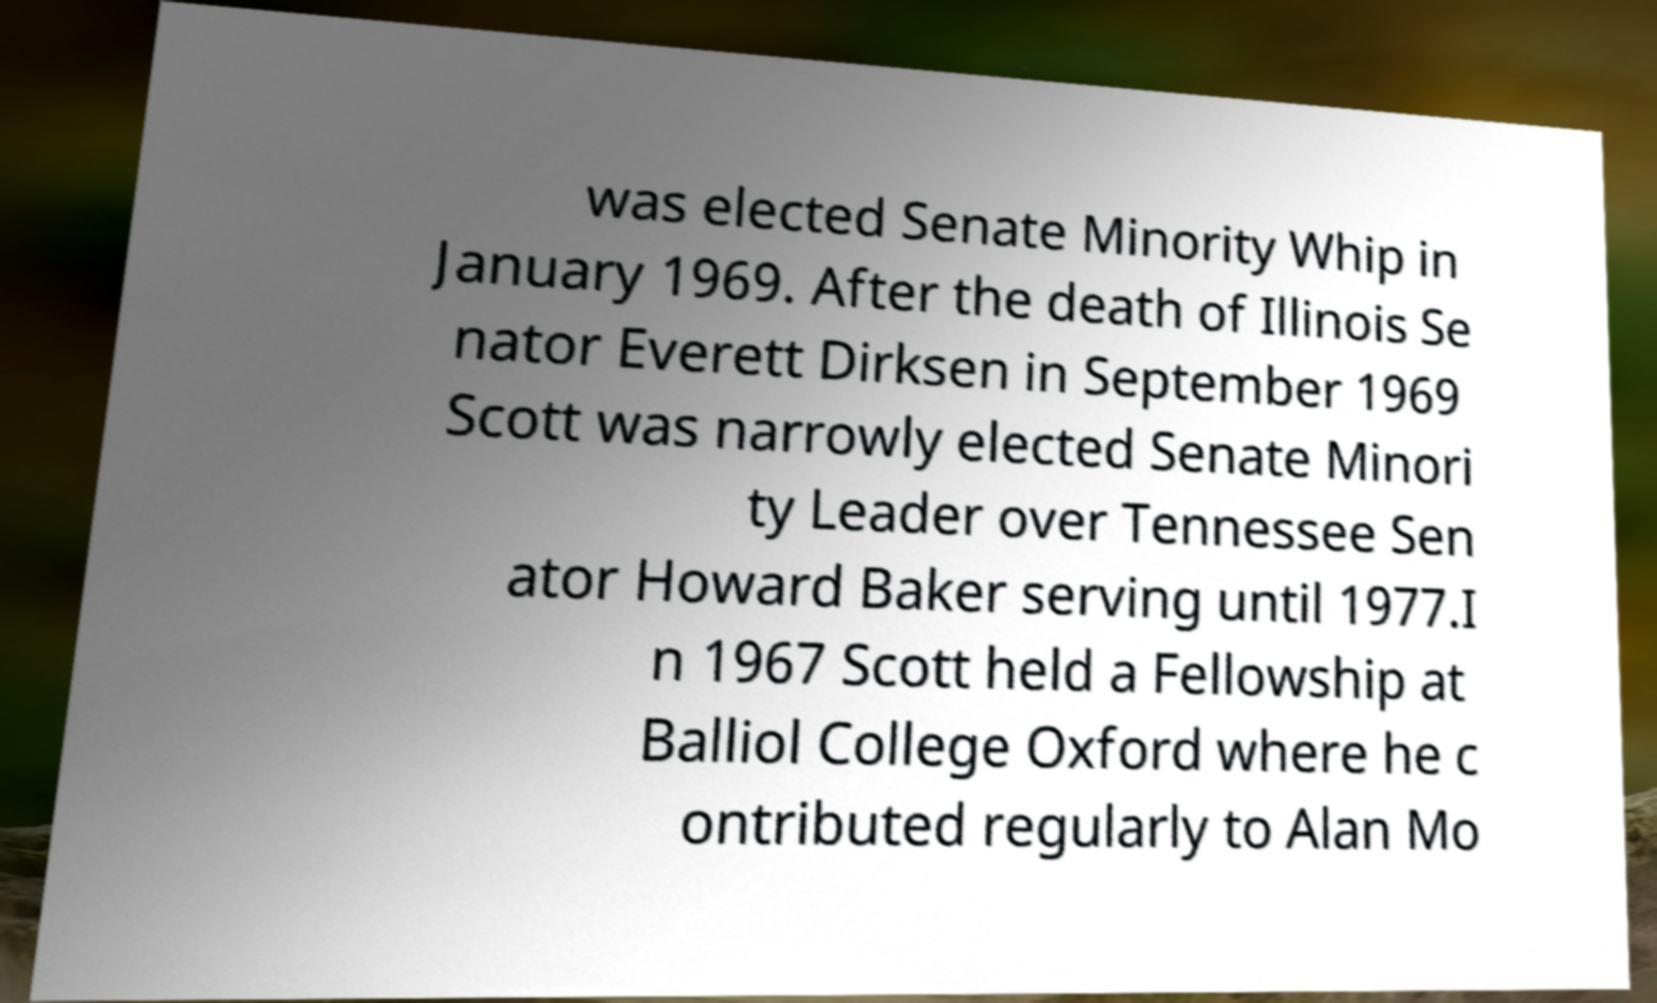I need the written content from this picture converted into text. Can you do that? was elected Senate Minority Whip in January 1969. After the death of Illinois Se nator Everett Dirksen in September 1969 Scott was narrowly elected Senate Minori ty Leader over Tennessee Sen ator Howard Baker serving until 1977.I n 1967 Scott held a Fellowship at Balliol College Oxford where he c ontributed regularly to Alan Mo 